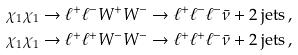Convert formula to latex. <formula><loc_0><loc_0><loc_500><loc_500>& \chi _ { 1 } \chi _ { 1 } \to \ell ^ { + } \ell ^ { - } W ^ { + } W ^ { - } \to \ell ^ { + } \ell ^ { - } \ell ^ { - } \bar { \nu } + 2 \text { jets} \, , \\ & \chi _ { 1 } \chi _ { 1 } \to \ell ^ { + } \ell ^ { + } W ^ { - } W ^ { - } \to \ell ^ { + } \ell ^ { + } \ell ^ { - } \bar { \nu } + 2 \text { jets} \, ,</formula> 